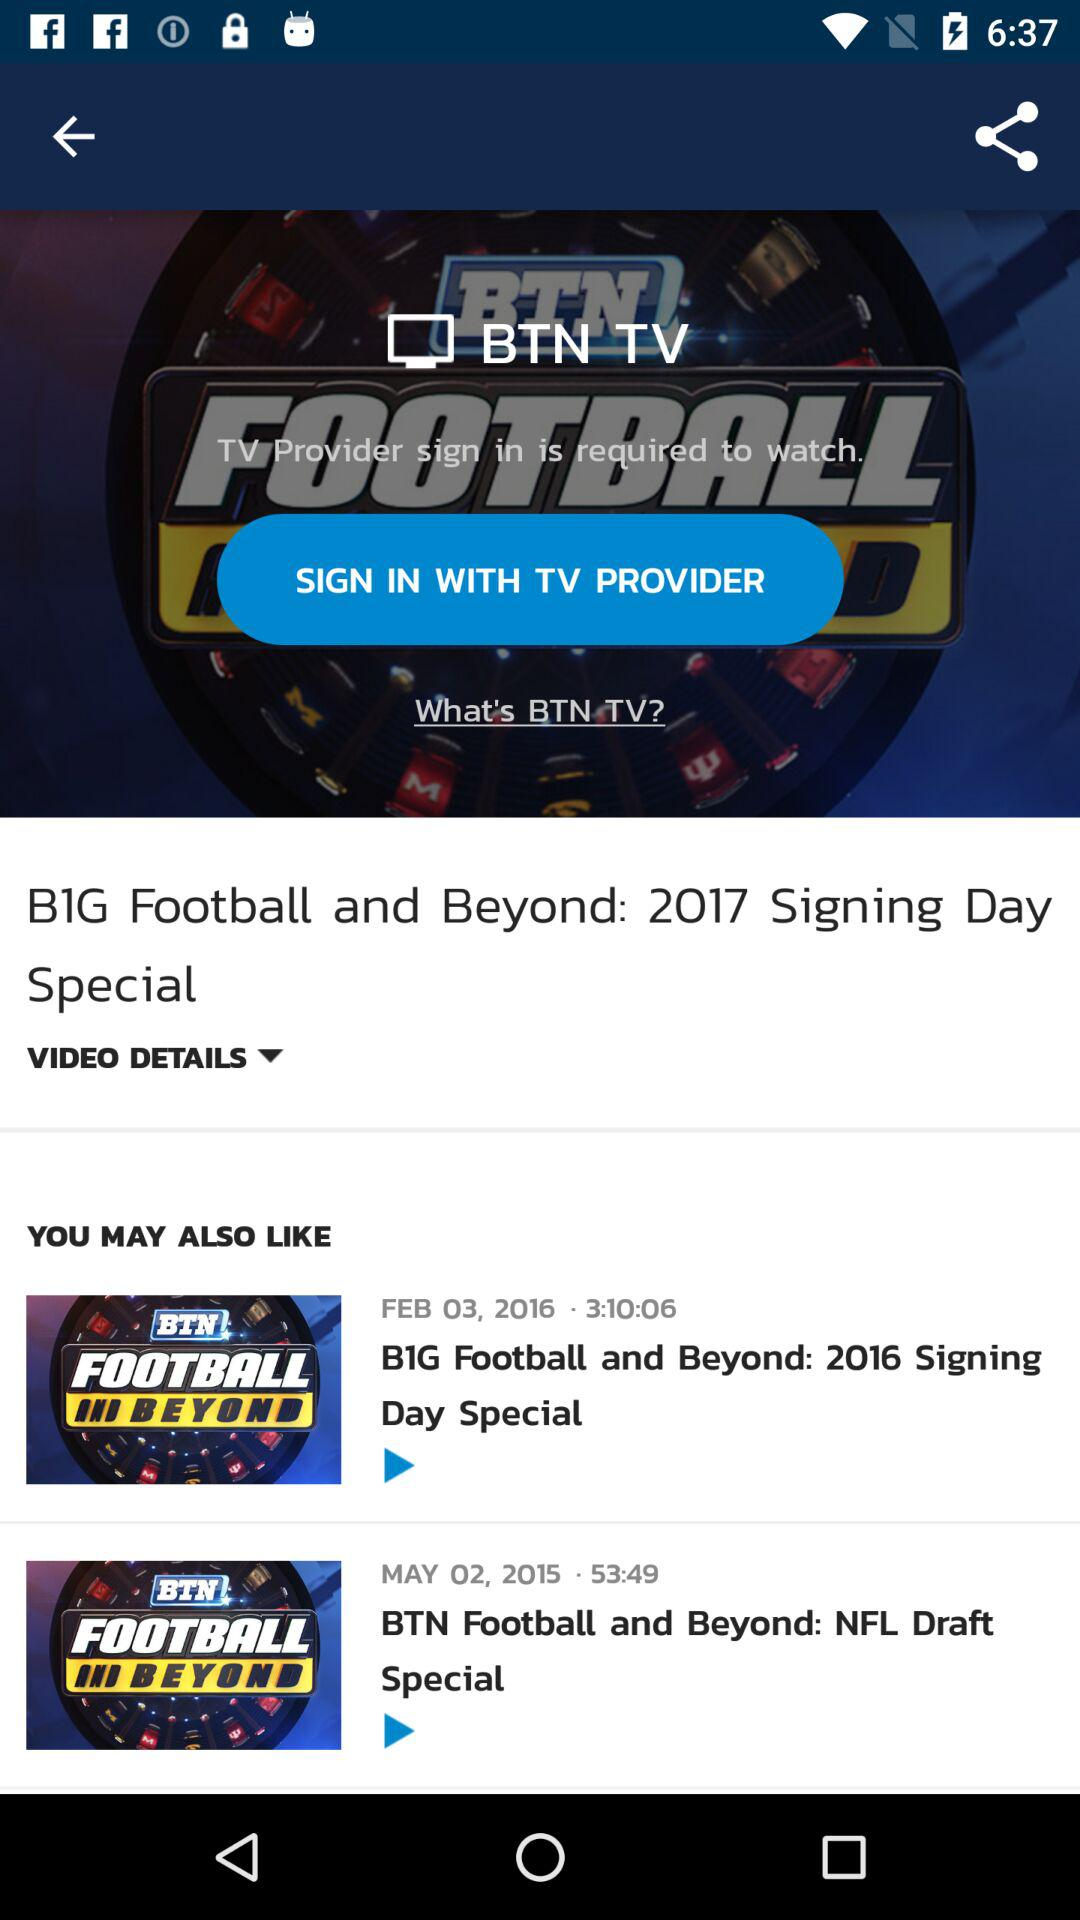What is the time duration of the video "BIG Football and Beyond: 2016 Signing Day Special"? The time duration of the video is 3 hours, 10 minutes, and 6 seconds. 